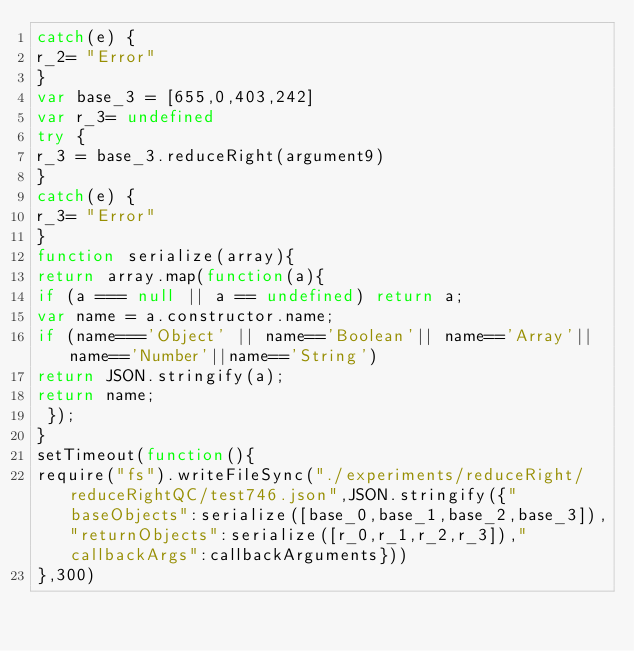Convert code to text. <code><loc_0><loc_0><loc_500><loc_500><_JavaScript_>catch(e) {
r_2= "Error"
}
var base_3 = [655,0,403,242]
var r_3= undefined
try {
r_3 = base_3.reduceRight(argument9)
}
catch(e) {
r_3= "Error"
}
function serialize(array){
return array.map(function(a){
if (a === null || a == undefined) return a;
var name = a.constructor.name;
if (name==='Object' || name=='Boolean'|| name=='Array'||name=='Number'||name=='String')
return JSON.stringify(a);
return name;
 });
}
setTimeout(function(){
require("fs").writeFileSync("./experiments/reduceRight/reduceRightQC/test746.json",JSON.stringify({"baseObjects":serialize([base_0,base_1,base_2,base_3]),"returnObjects":serialize([r_0,r_1,r_2,r_3]),"callbackArgs":callbackArguments}))
},300)</code> 